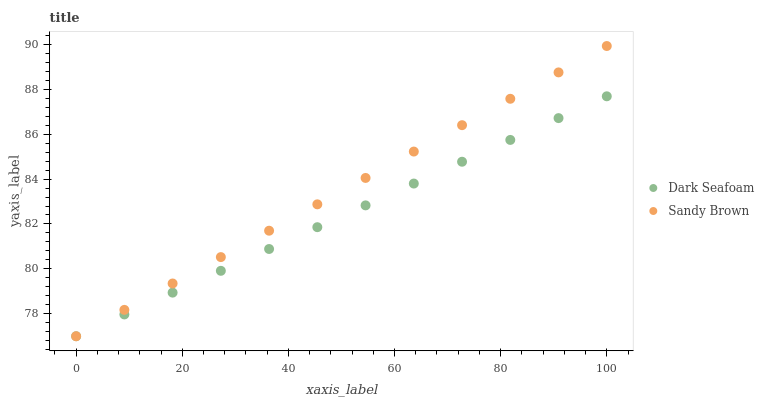Does Dark Seafoam have the minimum area under the curve?
Answer yes or no. Yes. Does Sandy Brown have the maximum area under the curve?
Answer yes or no. Yes. Does Sandy Brown have the minimum area under the curve?
Answer yes or no. No. Is Sandy Brown the smoothest?
Answer yes or no. Yes. Is Dark Seafoam the roughest?
Answer yes or no. Yes. Is Sandy Brown the roughest?
Answer yes or no. No. Does Dark Seafoam have the lowest value?
Answer yes or no. Yes. Does Sandy Brown have the highest value?
Answer yes or no. Yes. Does Sandy Brown intersect Dark Seafoam?
Answer yes or no. Yes. Is Sandy Brown less than Dark Seafoam?
Answer yes or no. No. Is Sandy Brown greater than Dark Seafoam?
Answer yes or no. No. 